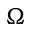Convert formula to latex. <formula><loc_0><loc_0><loc_500><loc_500>\Omega</formula> 